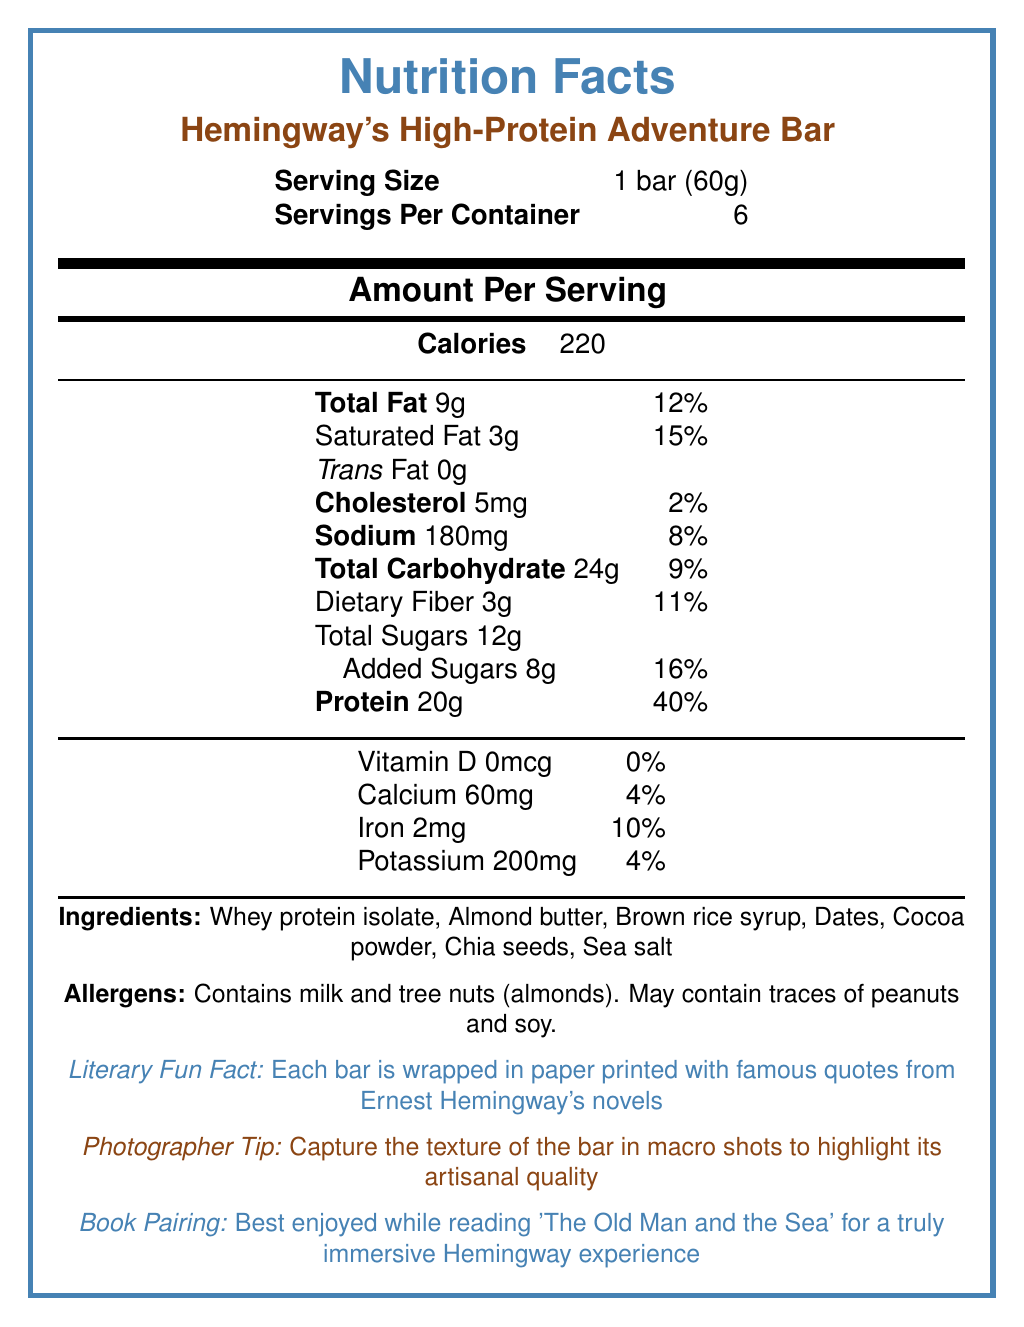what is the serving size of Hemingway's High-Protein Adventure Bar? The serving size is specified as 1 bar (60g) in the document.
Answer: 1 bar (60g) how many servings are in one container? The document states that there are 6 servings per container.
Answer: 6 how many calories are there per serving? The document lists the calorie count per serving as 220.
Answer: 220 what is the total amount of fat per serving? The total fat per serving is noted as 9g in the document.
Answer: 9g how much protein does one serving contain? The document mentions that one serving contains 20g of protein.
Answer: 20g how many grams of saturated fat are there per serving? A. 1g B. 2g C. 3g D. 4g The document indicates that the saturated fat per serving is 3g.
Answer: C. 3g what is the percentage of daily value for calcium provided per serving? A. 2% B. 4% C. 6% D. 8% The document shows that calcium per serving meets 4% of the daily value.
Answer: B. 4% is there any trans fat in a serving of the bar? The document states that the trans fat per serving is 0g.
Answer: No is the bar suitable for someone allergic to peanuts? The document expresses that it may contain traces of peanuts.
Answer: No list the ingredients in the Hemingway's High-Protein Adventure Bar. The ingredients are explicitly listed in the document.
Answer: Whey protein isolate, Almond butter, Brown rice syrup, Dates, Cocoa powder, Chia seeds, Sea salt mention one literary fun fact related to the Hemingway's High-Protein Adventure Bar The document includes this fun fact under a specified section.
Answer: Each bar is wrapped in paper printed with famous quotes from Ernest Hemingway's novels how much daily value of dietary fiber does one serving provide? The document indicates that one serving provides 11% of the daily value for dietary fiber.
Answer: 11% how much sodium is in a serving of the bar? The document specifies that one serving contains 180mg of sodium.
Answer: 180mg does this product contain any milk? The document states that it contains milk under the allergens section.
Answer: Yes suggest a book to pair with Hemingway's High-Protein Adventure Bar for an immersive experience The document suggests this book pairing for an immersive experience.
Answer: 'The Old Man and the Sea' what is the daily value percentage for added sugars per serving? The document indicates that added sugars meet 16% of the daily value per serving.
Answer: 16% what is the dietary fiber content in the bar? A. 2g B. 3g C. 4g D. 5g The document specifies that the dietary fiber content is 3g per serving.
Answer: B. 3g does the document specify any photographer tips? The document specifies to capture the texture of the bar in macro shots to highlight its artisanal quality.
Answer: Yes provide a brief summary of the Hemingway's High-Protein Adventure Bar's nutrition facts label. This summary encapsulates the key nutritional information, allergen details, and additional fun facts and suggestions found in the document.
Answer: Hemingway's High-Protein Adventure Bar has a serving size of 1 bar (60g), featuring 220 calories per serving. Each bar contains 9g of total fat, 20g of protein, and 24g of total carbohydrates. It includes 3g of dietary fiber and 12g of total sugars, 8g of which are added sugars. It also provides 60mg of calcium, 2mg of iron, and 200mg of potassium per serving. The product contains allergens like milk and tree nuts (almonds) and may have traces of peanuts and soy. The bar also comes with a literary fun fact and a suggestion to pair with "The Old Man and the Sea." what is the manufacturing location for Hemingway's High-Protein Adventure Bar? The document does not provide information about the manufacturing location.
Answer: Not enough information 